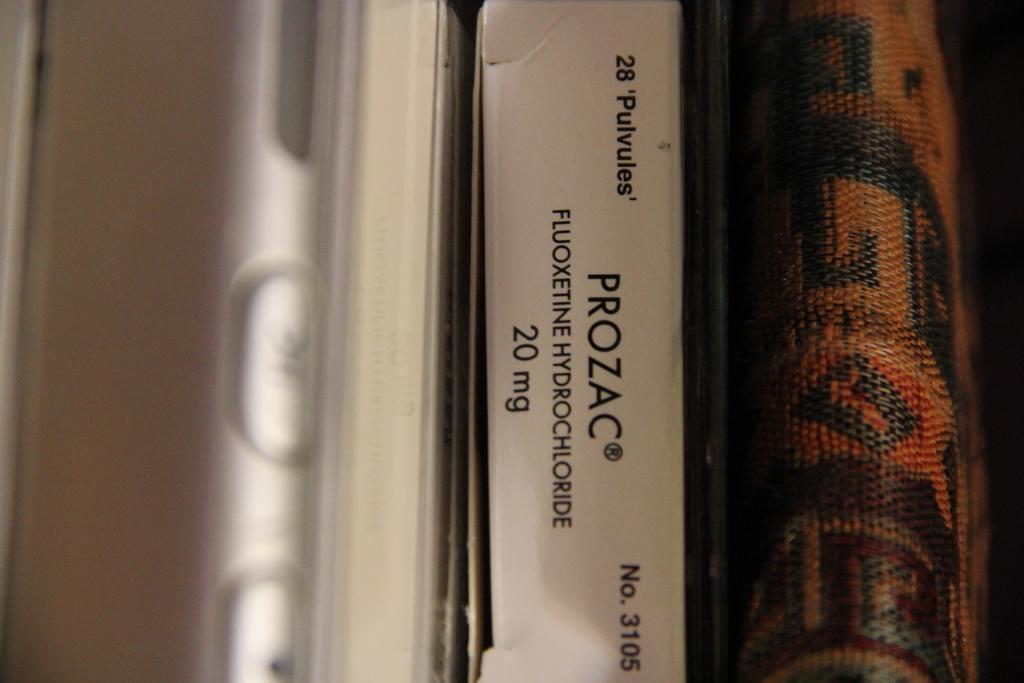<image>
Summarize the visual content of the image. Between a cellphone and a wallet sits a package of Prozac. 